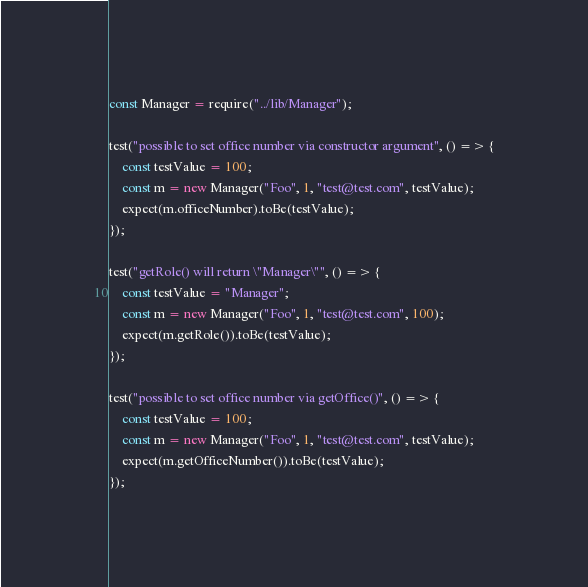<code> <loc_0><loc_0><loc_500><loc_500><_JavaScript_>const Manager = require("../lib/Manager");

test("possible to set office number via constructor argument", () => {
    const testValue = 100;
    const m = new Manager("Foo", 1, "test@test.com", testValue);
    expect(m.officeNumber).toBe(testValue);
});

test("getRole() will return \"Manager\"", () => {
    const testValue = "Manager";
    const m = new Manager("Foo", 1, "test@test.com", 100);
    expect(m.getRole()).toBe(testValue);
});

test("possible to set office number via getOffice()", () => {
    const testValue = 100;
    const m = new Manager("Foo", 1, "test@test.com", testValue);
    expect(m.getOfficeNumber()).toBe(testValue);
});</code> 